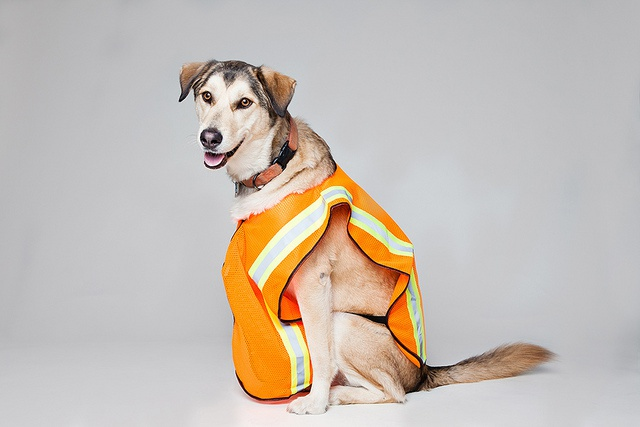Describe the objects in this image and their specific colors. I can see a dog in darkgray, lightgray, orange, and tan tones in this image. 